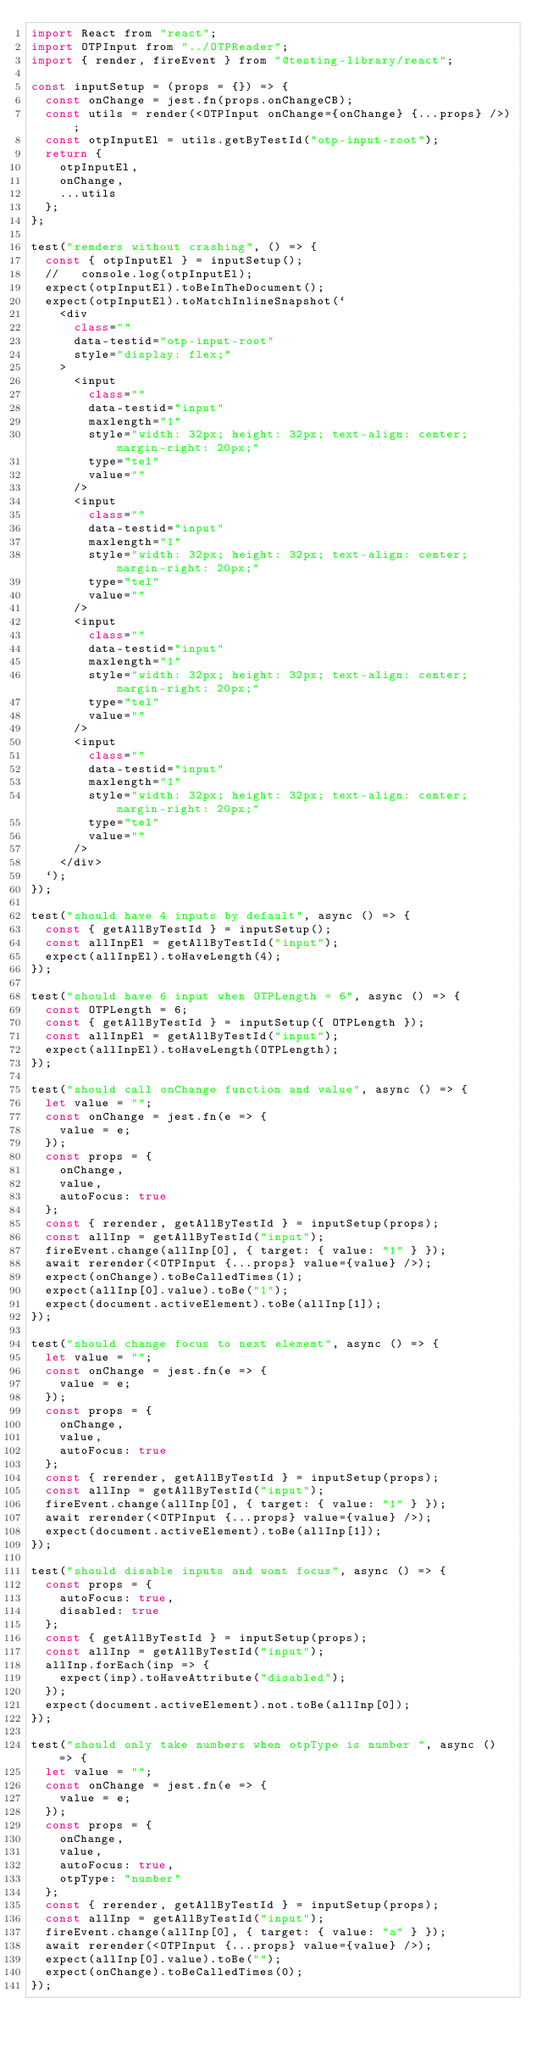<code> <loc_0><loc_0><loc_500><loc_500><_JavaScript_>import React from "react";
import OTPInput from "../OTPReader";
import { render, fireEvent } from "@testing-library/react";

const inputSetup = (props = {}) => {
  const onChange = jest.fn(props.onChangeCB);
  const utils = render(<OTPInput onChange={onChange} {...props} />);
  const otpInputEl = utils.getByTestId("otp-input-root");
  return {
    otpInputEl,
    onChange,
    ...utils
  };
};

test("renders without crashing", () => {
  const { otpInputEl } = inputSetup();
  //   console.log(otpInputEl);
  expect(otpInputEl).toBeInTheDocument();
  expect(otpInputEl).toMatchInlineSnapshot(`
    <div
      class=""
      data-testid="otp-input-root"
      style="display: flex;"
    >
      <input
        class=""
        data-testid="input"
        maxlength="1"
        style="width: 32px; height: 32px; text-align: center; margin-right: 20px;"
        type="tel"
        value=""
      />
      <input
        class=""
        data-testid="input"
        maxlength="1"
        style="width: 32px; height: 32px; text-align: center; margin-right: 20px;"
        type="tel"
        value=""
      />
      <input
        class=""
        data-testid="input"
        maxlength="1"
        style="width: 32px; height: 32px; text-align: center; margin-right: 20px;"
        type="tel"
        value=""
      />
      <input
        class=""
        data-testid="input"
        maxlength="1"
        style="width: 32px; height: 32px; text-align: center; margin-right: 20px;"
        type="tel"
        value=""
      />
    </div>
  `);
});

test("should have 4 inputs by default", async () => {
  const { getAllByTestId } = inputSetup();
  const allInpEl = getAllByTestId("input");
  expect(allInpEl).toHaveLength(4);
});

test("should have 6 input when OTPLength = 6", async () => {
  const OTPLength = 6;
  const { getAllByTestId } = inputSetup({ OTPLength });
  const allInpEl = getAllByTestId("input");
  expect(allInpEl).toHaveLength(OTPLength);
});

test("should call onChange function and value", async () => {
  let value = "";
  const onChange = jest.fn(e => {
    value = e;
  });
  const props = {
    onChange,
    value,
    autoFocus: true
  };
  const { rerender, getAllByTestId } = inputSetup(props);
  const allInp = getAllByTestId("input");
  fireEvent.change(allInp[0], { target: { value: "1" } });
  await rerender(<OTPInput {...props} value={value} />);
  expect(onChange).toBeCalledTimes(1);
  expect(allInp[0].value).toBe("1");
  expect(document.activeElement).toBe(allInp[1]);
});

test("should change focus to next element", async () => {
  let value = "";
  const onChange = jest.fn(e => {
    value = e;
  });
  const props = {
    onChange,
    value,
    autoFocus: true
  };
  const { rerender, getAllByTestId } = inputSetup(props);
  const allInp = getAllByTestId("input");
  fireEvent.change(allInp[0], { target: { value: "1" } });
  await rerender(<OTPInput {...props} value={value} />);
  expect(document.activeElement).toBe(allInp[1]);
});

test("should disable inputs and wont focus", async () => {
  const props = {
    autoFocus: true,
    disabled: true
  };
  const { getAllByTestId } = inputSetup(props);
  const allInp = getAllByTestId("input");
  allInp.forEach(inp => {
    expect(inp).toHaveAttribute("disabled");
  });
  expect(document.activeElement).not.toBe(allInp[0]);
});

test("should only take numbers when otpType is number ", async () => {
  let value = "";
  const onChange = jest.fn(e => {
    value = e;
  });
  const props = {
    onChange,
    value,
    autoFocus: true,
    otpType: "number"
  };
  const { rerender, getAllByTestId } = inputSetup(props);
  const allInp = getAllByTestId("input");
  fireEvent.change(allInp[0], { target: { value: "a" } });
  await rerender(<OTPInput {...props} value={value} />);
  expect(allInp[0].value).toBe("");
  expect(onChange).toBeCalledTimes(0);
});
</code> 